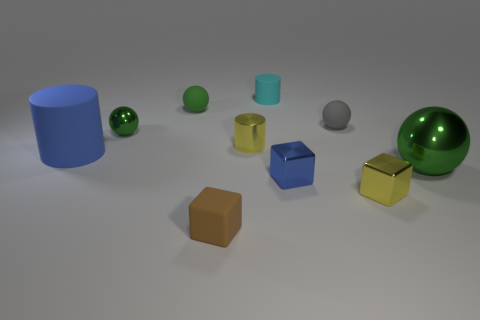There is a cylinder that is to the right of the yellow cylinder; what number of tiny rubber cylinders are to the left of it?
Provide a succinct answer. 0. There is a large thing behind the green ball that is in front of the big rubber cylinder; what is its color?
Offer a terse response. Blue. The object that is both behind the small metallic ball and in front of the tiny green matte thing is made of what material?
Keep it short and to the point. Rubber. Are there any tiny yellow shiny objects that have the same shape as the tiny cyan matte object?
Ensure brevity in your answer.  Yes. Do the small yellow shiny object that is to the left of the cyan cylinder and the blue rubber object have the same shape?
Your answer should be very brief. Yes. What number of objects are both behind the small yellow cube and on the right side of the small gray object?
Give a very brief answer. 1. There is a large thing to the right of the tiny brown matte block; what is its shape?
Your answer should be very brief. Sphere. What number of tiny cylinders have the same material as the gray thing?
Give a very brief answer. 1. There is a tiny brown rubber object; is its shape the same as the blue thing to the right of the brown rubber object?
Make the answer very short. Yes. Are there any small rubber objects that are in front of the green ball that is behind the green metallic ball that is to the left of the big green thing?
Your answer should be very brief. Yes. 